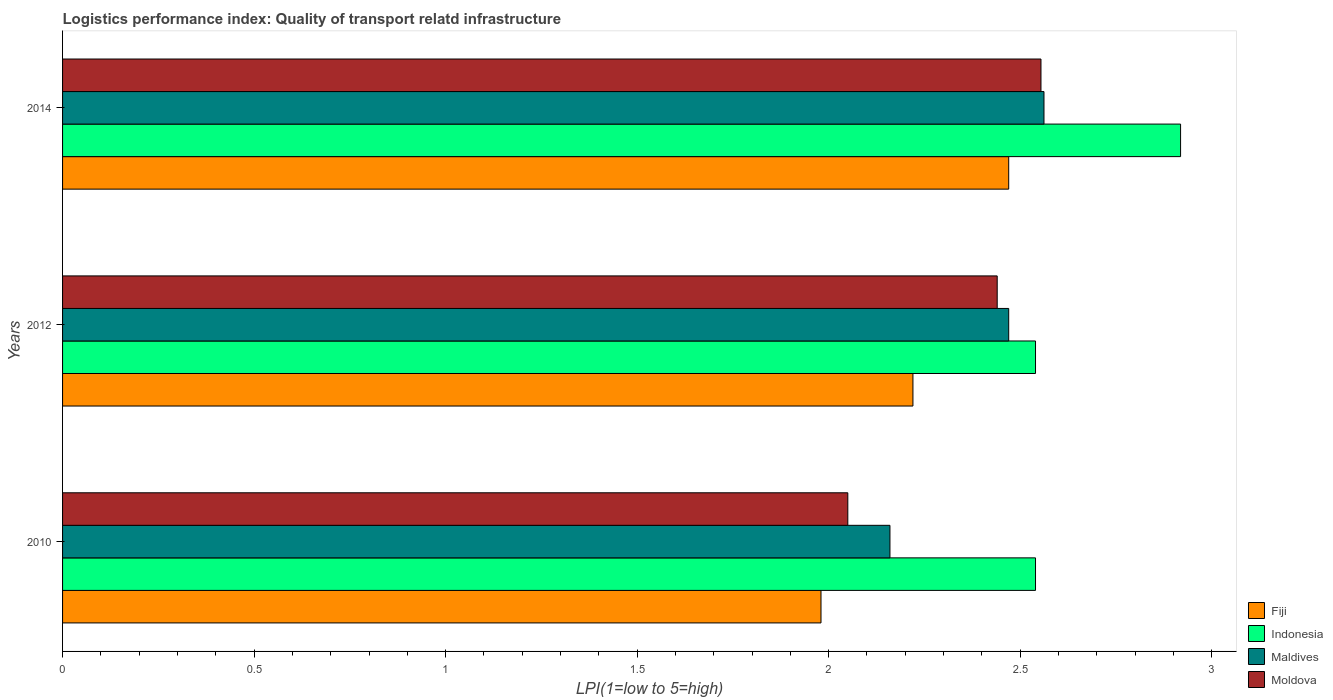How many different coloured bars are there?
Provide a succinct answer. 4. How many bars are there on the 1st tick from the bottom?
Provide a succinct answer. 4. What is the logistics performance index in Fiji in 2014?
Keep it short and to the point. 2.47. Across all years, what is the maximum logistics performance index in Fiji?
Provide a succinct answer. 2.47. Across all years, what is the minimum logistics performance index in Indonesia?
Your response must be concise. 2.54. What is the total logistics performance index in Maldives in the graph?
Keep it short and to the point. 7.19. What is the difference between the logistics performance index in Moldova in 2012 and that in 2014?
Provide a succinct answer. -0.11. What is the difference between the logistics performance index in Indonesia in 2010 and the logistics performance index in Fiji in 2014?
Offer a very short reply. 0.07. What is the average logistics performance index in Moldova per year?
Your answer should be very brief. 2.35. In the year 2012, what is the difference between the logistics performance index in Fiji and logistics performance index in Indonesia?
Your answer should be compact. -0.32. What is the ratio of the logistics performance index in Fiji in 2012 to that in 2014?
Provide a succinct answer. 0.9. Is the difference between the logistics performance index in Fiji in 2010 and 2012 greater than the difference between the logistics performance index in Indonesia in 2010 and 2012?
Offer a very short reply. No. What is the difference between the highest and the second highest logistics performance index in Indonesia?
Provide a succinct answer. 0.38. What is the difference between the highest and the lowest logistics performance index in Fiji?
Offer a terse response. 0.49. In how many years, is the logistics performance index in Moldova greater than the average logistics performance index in Moldova taken over all years?
Make the answer very short. 2. Is it the case that in every year, the sum of the logistics performance index in Maldives and logistics performance index in Moldova is greater than the sum of logistics performance index in Fiji and logistics performance index in Indonesia?
Keep it short and to the point. No. What does the 3rd bar from the bottom in 2012 represents?
Offer a very short reply. Maldives. How many bars are there?
Offer a terse response. 12. How many years are there in the graph?
Ensure brevity in your answer.  3. What is the difference between two consecutive major ticks on the X-axis?
Your answer should be compact. 0.5. Does the graph contain grids?
Your response must be concise. No. How are the legend labels stacked?
Give a very brief answer. Vertical. What is the title of the graph?
Provide a succinct answer. Logistics performance index: Quality of transport relatd infrastructure. Does "Liberia" appear as one of the legend labels in the graph?
Your answer should be very brief. No. What is the label or title of the X-axis?
Offer a very short reply. LPI(1=low to 5=high). What is the label or title of the Y-axis?
Provide a short and direct response. Years. What is the LPI(1=low to 5=high) in Fiji in 2010?
Provide a short and direct response. 1.98. What is the LPI(1=low to 5=high) of Indonesia in 2010?
Offer a terse response. 2.54. What is the LPI(1=low to 5=high) in Maldives in 2010?
Your answer should be compact. 2.16. What is the LPI(1=low to 5=high) of Moldova in 2010?
Offer a very short reply. 2.05. What is the LPI(1=low to 5=high) in Fiji in 2012?
Provide a succinct answer. 2.22. What is the LPI(1=low to 5=high) of Indonesia in 2012?
Give a very brief answer. 2.54. What is the LPI(1=low to 5=high) in Maldives in 2012?
Your answer should be compact. 2.47. What is the LPI(1=low to 5=high) in Moldova in 2012?
Offer a very short reply. 2.44. What is the LPI(1=low to 5=high) in Fiji in 2014?
Keep it short and to the point. 2.47. What is the LPI(1=low to 5=high) of Indonesia in 2014?
Your response must be concise. 2.92. What is the LPI(1=low to 5=high) in Maldives in 2014?
Your response must be concise. 2.56. What is the LPI(1=low to 5=high) in Moldova in 2014?
Give a very brief answer. 2.55. Across all years, what is the maximum LPI(1=low to 5=high) in Fiji?
Give a very brief answer. 2.47. Across all years, what is the maximum LPI(1=low to 5=high) in Indonesia?
Offer a very short reply. 2.92. Across all years, what is the maximum LPI(1=low to 5=high) of Maldives?
Keep it short and to the point. 2.56. Across all years, what is the maximum LPI(1=low to 5=high) in Moldova?
Your answer should be very brief. 2.55. Across all years, what is the minimum LPI(1=low to 5=high) of Fiji?
Make the answer very short. 1.98. Across all years, what is the minimum LPI(1=low to 5=high) of Indonesia?
Offer a very short reply. 2.54. Across all years, what is the minimum LPI(1=low to 5=high) in Maldives?
Provide a succinct answer. 2.16. Across all years, what is the minimum LPI(1=low to 5=high) in Moldova?
Make the answer very short. 2.05. What is the total LPI(1=low to 5=high) in Fiji in the graph?
Your answer should be very brief. 6.67. What is the total LPI(1=low to 5=high) of Indonesia in the graph?
Make the answer very short. 8. What is the total LPI(1=low to 5=high) of Maldives in the graph?
Your response must be concise. 7.19. What is the total LPI(1=low to 5=high) of Moldova in the graph?
Ensure brevity in your answer.  7.04. What is the difference between the LPI(1=low to 5=high) in Fiji in 2010 and that in 2012?
Ensure brevity in your answer.  -0.24. What is the difference between the LPI(1=low to 5=high) in Indonesia in 2010 and that in 2012?
Your answer should be compact. 0. What is the difference between the LPI(1=low to 5=high) of Maldives in 2010 and that in 2012?
Provide a succinct answer. -0.31. What is the difference between the LPI(1=low to 5=high) of Moldova in 2010 and that in 2012?
Your response must be concise. -0.39. What is the difference between the LPI(1=low to 5=high) in Fiji in 2010 and that in 2014?
Your answer should be compact. -0.49. What is the difference between the LPI(1=low to 5=high) of Indonesia in 2010 and that in 2014?
Ensure brevity in your answer.  -0.38. What is the difference between the LPI(1=low to 5=high) in Maldives in 2010 and that in 2014?
Offer a very short reply. -0.4. What is the difference between the LPI(1=low to 5=high) of Moldova in 2010 and that in 2014?
Make the answer very short. -0.5. What is the difference between the LPI(1=low to 5=high) of Fiji in 2012 and that in 2014?
Offer a very short reply. -0.25. What is the difference between the LPI(1=low to 5=high) of Indonesia in 2012 and that in 2014?
Your answer should be very brief. -0.38. What is the difference between the LPI(1=low to 5=high) in Maldives in 2012 and that in 2014?
Your response must be concise. -0.09. What is the difference between the LPI(1=low to 5=high) of Moldova in 2012 and that in 2014?
Ensure brevity in your answer.  -0.11. What is the difference between the LPI(1=low to 5=high) of Fiji in 2010 and the LPI(1=low to 5=high) of Indonesia in 2012?
Offer a very short reply. -0.56. What is the difference between the LPI(1=low to 5=high) in Fiji in 2010 and the LPI(1=low to 5=high) in Maldives in 2012?
Make the answer very short. -0.49. What is the difference between the LPI(1=low to 5=high) in Fiji in 2010 and the LPI(1=low to 5=high) in Moldova in 2012?
Keep it short and to the point. -0.46. What is the difference between the LPI(1=low to 5=high) in Indonesia in 2010 and the LPI(1=low to 5=high) in Maldives in 2012?
Offer a very short reply. 0.07. What is the difference between the LPI(1=low to 5=high) of Maldives in 2010 and the LPI(1=low to 5=high) of Moldova in 2012?
Provide a short and direct response. -0.28. What is the difference between the LPI(1=low to 5=high) of Fiji in 2010 and the LPI(1=low to 5=high) of Indonesia in 2014?
Offer a terse response. -0.94. What is the difference between the LPI(1=low to 5=high) of Fiji in 2010 and the LPI(1=low to 5=high) of Maldives in 2014?
Offer a very short reply. -0.58. What is the difference between the LPI(1=low to 5=high) of Fiji in 2010 and the LPI(1=low to 5=high) of Moldova in 2014?
Give a very brief answer. -0.57. What is the difference between the LPI(1=low to 5=high) in Indonesia in 2010 and the LPI(1=low to 5=high) in Maldives in 2014?
Offer a very short reply. -0.02. What is the difference between the LPI(1=low to 5=high) of Indonesia in 2010 and the LPI(1=low to 5=high) of Moldova in 2014?
Offer a very short reply. -0.01. What is the difference between the LPI(1=low to 5=high) in Maldives in 2010 and the LPI(1=low to 5=high) in Moldova in 2014?
Keep it short and to the point. -0.39. What is the difference between the LPI(1=low to 5=high) of Fiji in 2012 and the LPI(1=low to 5=high) of Indonesia in 2014?
Give a very brief answer. -0.7. What is the difference between the LPI(1=low to 5=high) in Fiji in 2012 and the LPI(1=low to 5=high) in Maldives in 2014?
Your answer should be compact. -0.34. What is the difference between the LPI(1=low to 5=high) in Fiji in 2012 and the LPI(1=low to 5=high) in Moldova in 2014?
Provide a succinct answer. -0.33. What is the difference between the LPI(1=low to 5=high) of Indonesia in 2012 and the LPI(1=low to 5=high) of Maldives in 2014?
Make the answer very short. -0.02. What is the difference between the LPI(1=low to 5=high) in Indonesia in 2012 and the LPI(1=low to 5=high) in Moldova in 2014?
Give a very brief answer. -0.01. What is the difference between the LPI(1=low to 5=high) in Maldives in 2012 and the LPI(1=low to 5=high) in Moldova in 2014?
Give a very brief answer. -0.08. What is the average LPI(1=low to 5=high) of Fiji per year?
Keep it short and to the point. 2.22. What is the average LPI(1=low to 5=high) of Indonesia per year?
Provide a short and direct response. 2.67. What is the average LPI(1=low to 5=high) of Maldives per year?
Keep it short and to the point. 2.4. What is the average LPI(1=low to 5=high) of Moldova per year?
Your answer should be very brief. 2.35. In the year 2010, what is the difference between the LPI(1=low to 5=high) of Fiji and LPI(1=low to 5=high) of Indonesia?
Your answer should be compact. -0.56. In the year 2010, what is the difference between the LPI(1=low to 5=high) in Fiji and LPI(1=low to 5=high) in Maldives?
Your answer should be very brief. -0.18. In the year 2010, what is the difference between the LPI(1=low to 5=high) of Fiji and LPI(1=low to 5=high) of Moldova?
Provide a short and direct response. -0.07. In the year 2010, what is the difference between the LPI(1=low to 5=high) of Indonesia and LPI(1=low to 5=high) of Maldives?
Offer a terse response. 0.38. In the year 2010, what is the difference between the LPI(1=low to 5=high) in Indonesia and LPI(1=low to 5=high) in Moldova?
Make the answer very short. 0.49. In the year 2010, what is the difference between the LPI(1=low to 5=high) in Maldives and LPI(1=low to 5=high) in Moldova?
Ensure brevity in your answer.  0.11. In the year 2012, what is the difference between the LPI(1=low to 5=high) of Fiji and LPI(1=low to 5=high) of Indonesia?
Offer a very short reply. -0.32. In the year 2012, what is the difference between the LPI(1=low to 5=high) of Fiji and LPI(1=low to 5=high) of Moldova?
Your response must be concise. -0.22. In the year 2012, what is the difference between the LPI(1=low to 5=high) of Indonesia and LPI(1=low to 5=high) of Maldives?
Offer a very short reply. 0.07. In the year 2014, what is the difference between the LPI(1=low to 5=high) in Fiji and LPI(1=low to 5=high) in Indonesia?
Offer a very short reply. -0.45. In the year 2014, what is the difference between the LPI(1=low to 5=high) in Fiji and LPI(1=low to 5=high) in Maldives?
Your response must be concise. -0.09. In the year 2014, what is the difference between the LPI(1=low to 5=high) of Fiji and LPI(1=low to 5=high) of Moldova?
Give a very brief answer. -0.08. In the year 2014, what is the difference between the LPI(1=low to 5=high) in Indonesia and LPI(1=low to 5=high) in Maldives?
Ensure brevity in your answer.  0.36. In the year 2014, what is the difference between the LPI(1=low to 5=high) in Indonesia and LPI(1=low to 5=high) in Moldova?
Your response must be concise. 0.36. In the year 2014, what is the difference between the LPI(1=low to 5=high) in Maldives and LPI(1=low to 5=high) in Moldova?
Keep it short and to the point. 0.01. What is the ratio of the LPI(1=low to 5=high) in Fiji in 2010 to that in 2012?
Ensure brevity in your answer.  0.89. What is the ratio of the LPI(1=low to 5=high) of Maldives in 2010 to that in 2012?
Your answer should be very brief. 0.87. What is the ratio of the LPI(1=low to 5=high) of Moldova in 2010 to that in 2012?
Offer a very short reply. 0.84. What is the ratio of the LPI(1=low to 5=high) of Fiji in 2010 to that in 2014?
Provide a succinct answer. 0.8. What is the ratio of the LPI(1=low to 5=high) of Indonesia in 2010 to that in 2014?
Your answer should be compact. 0.87. What is the ratio of the LPI(1=low to 5=high) in Maldives in 2010 to that in 2014?
Provide a succinct answer. 0.84. What is the ratio of the LPI(1=low to 5=high) in Moldova in 2010 to that in 2014?
Keep it short and to the point. 0.8. What is the ratio of the LPI(1=low to 5=high) in Fiji in 2012 to that in 2014?
Provide a succinct answer. 0.9. What is the ratio of the LPI(1=low to 5=high) of Indonesia in 2012 to that in 2014?
Your answer should be compact. 0.87. What is the ratio of the LPI(1=low to 5=high) of Maldives in 2012 to that in 2014?
Offer a terse response. 0.96. What is the ratio of the LPI(1=low to 5=high) of Moldova in 2012 to that in 2014?
Give a very brief answer. 0.96. What is the difference between the highest and the second highest LPI(1=low to 5=high) in Fiji?
Make the answer very short. 0.25. What is the difference between the highest and the second highest LPI(1=low to 5=high) of Indonesia?
Ensure brevity in your answer.  0.38. What is the difference between the highest and the second highest LPI(1=low to 5=high) in Maldives?
Provide a short and direct response. 0.09. What is the difference between the highest and the second highest LPI(1=low to 5=high) of Moldova?
Make the answer very short. 0.11. What is the difference between the highest and the lowest LPI(1=low to 5=high) in Fiji?
Make the answer very short. 0.49. What is the difference between the highest and the lowest LPI(1=low to 5=high) in Indonesia?
Your answer should be very brief. 0.38. What is the difference between the highest and the lowest LPI(1=low to 5=high) of Maldives?
Ensure brevity in your answer.  0.4. What is the difference between the highest and the lowest LPI(1=low to 5=high) of Moldova?
Your answer should be very brief. 0.5. 